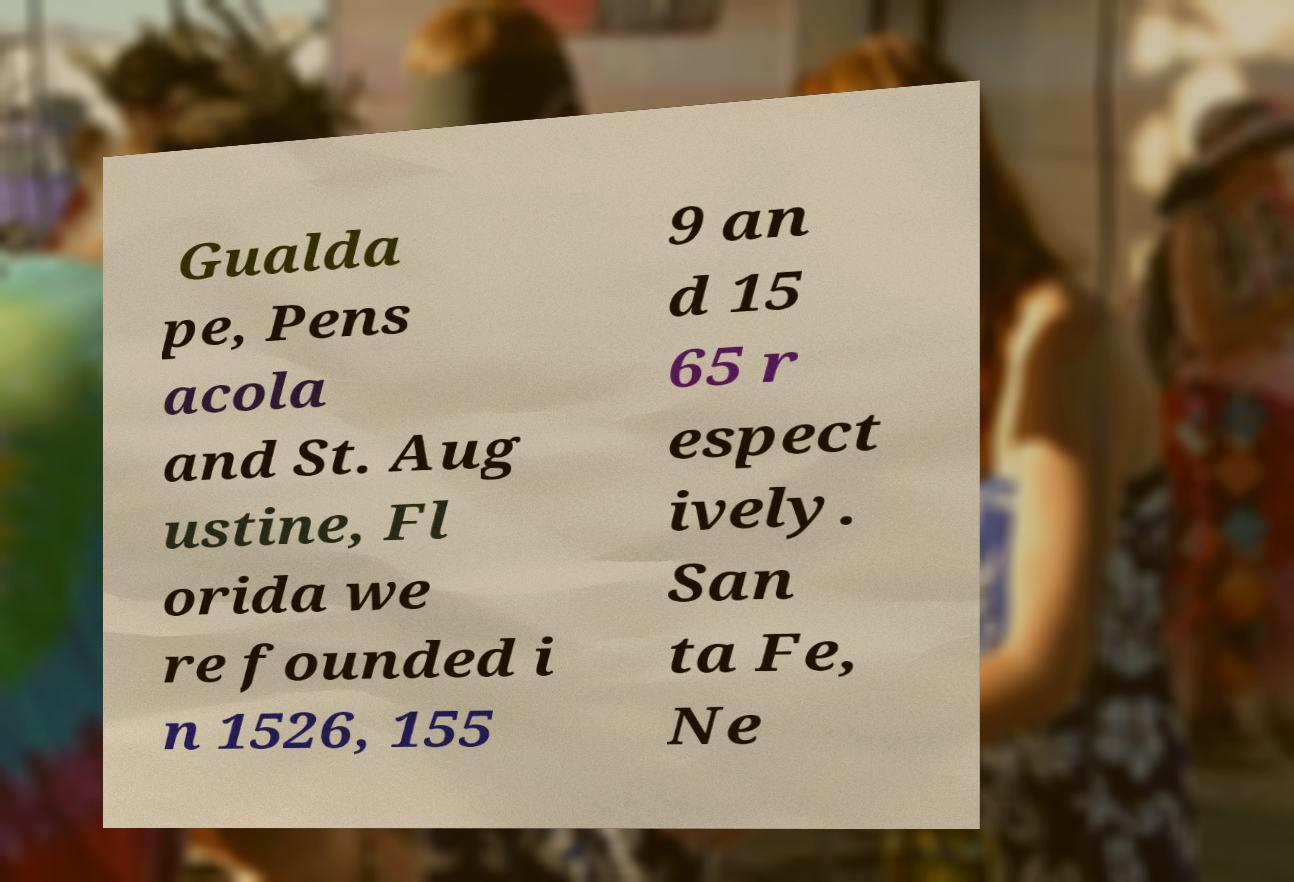What messages or text are displayed in this image? I need them in a readable, typed format. Gualda pe, Pens acola and St. Aug ustine, Fl orida we re founded i n 1526, 155 9 an d 15 65 r espect ively. San ta Fe, Ne 